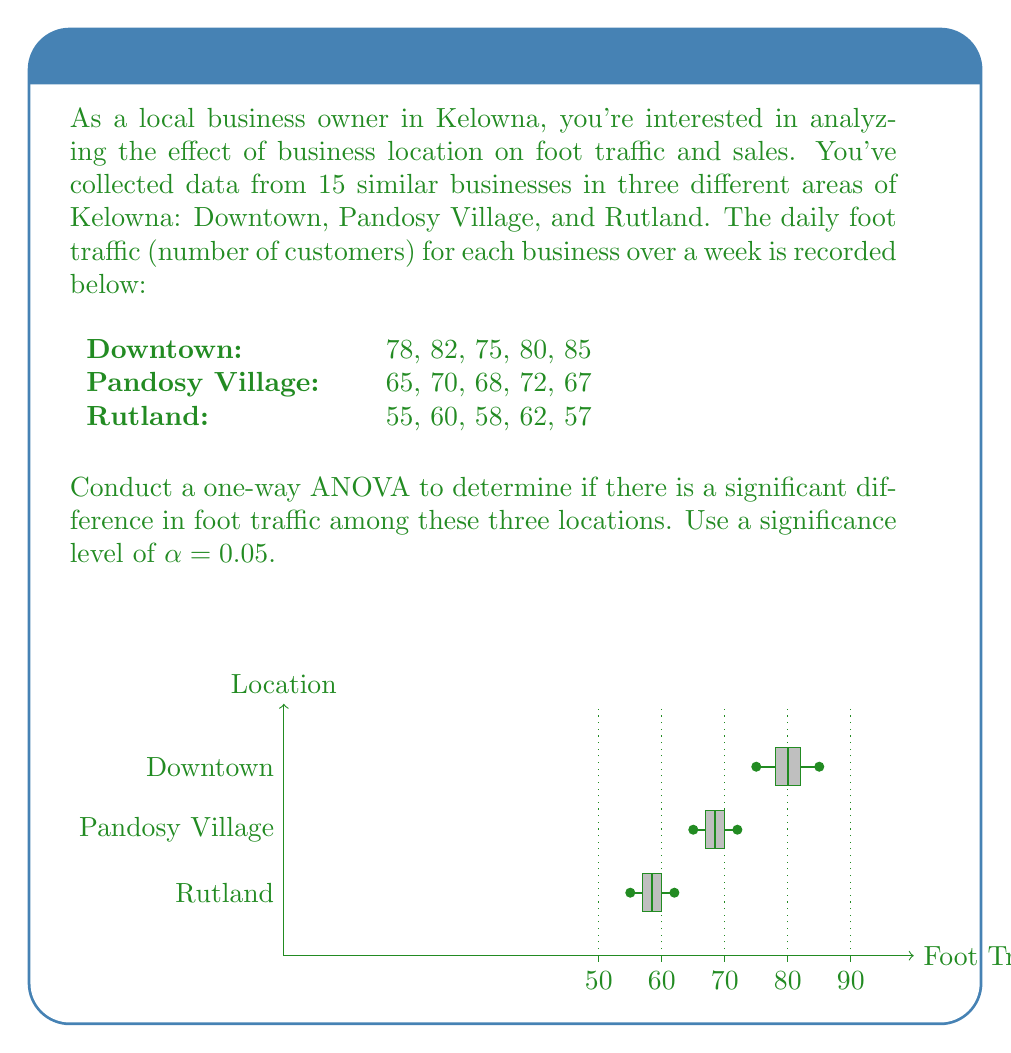Could you help me with this problem? Let's perform a one-way ANOVA step by step:

1) First, calculate the mean for each group and the overall mean:
   Downtown mean: $\bar{x}_1 = 80$
   Pandosy Village mean: $\bar{x}_2 = 68.4$
   Rutland mean: $\bar{x}_3 = 58.4$
   Overall mean: $\bar{x} = 70.6$

2) Calculate the Sum of Squares Between groups (SSB):
   $$SSB = n_1(\bar{x}_1 - \bar{x})^2 + n_2(\bar{x}_2 - \bar{x})^2 + n_3(\bar{x}_3 - \bar{x})^2$$
   $$SSB = 5(80 - 70.6)^2 + 5(68.4 - 70.6)^2 + 5(58.4 - 70.6)^2 = 1372.93$$

3) Calculate the Sum of Squares Within groups (SSW):
   $$SSW = \sum_{i=1}^{3}\sum_{j=1}^{n_i}(x_{ij} - \bar{x}_i)^2$$
   $$SSW = 82 + 12 + 62 = 156$$

4) Calculate the Sum of Squares Total (SST):
   $$SST = SSB + SSW = 1372.93 + 156 = 1528.93$$

5) Calculate the degrees of freedom:
   dfB (between) = k - 1 = 3 - 1 = 2
   dfW (within) = N - k = 15 - 3 = 12
   dfT (total) = N - 1 = 15 - 1 = 14

6) Calculate Mean Squares:
   $$MSB = \frac{SSB}{dfB} = \frac{1372.93}{2} = 686.465$$
   $$MSW = \frac{SSW}{dfW} = \frac{156}{12} = 13$$

7) Calculate the F-statistic:
   $$F = \frac{MSB}{MSW} = \frac{686.465}{13} = 52.805$$

8) Find the critical F-value:
   For α = 0.05, dfB = 2, dfW = 12, the critical F-value is approximately 3.89.

9) Compare the F-statistic to the critical F-value:
   Since 52.805 > 3.89, we reject the null hypothesis.

10) Calculate the p-value:
    The p-value for F(2,12) = 52.805 is much smaller than 0.05.
Answer: Reject null hypothesis; significant difference in foot traffic among locations (F(2,12) = 52.805, p < 0.05) 